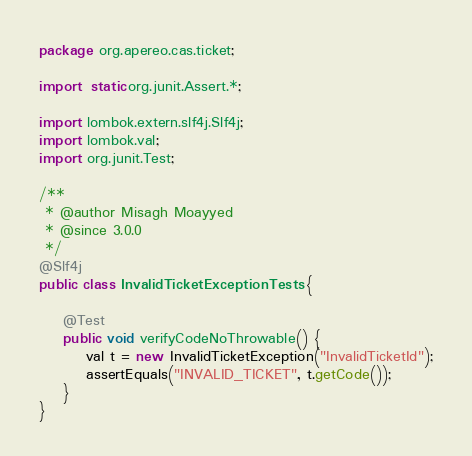Convert code to text. <code><loc_0><loc_0><loc_500><loc_500><_Java_>package org.apereo.cas.ticket;

import static org.junit.Assert.*;

import lombok.extern.slf4j.Slf4j;
import lombok.val;
import org.junit.Test;

/**
 * @author Misagh Moayyed
 * @since 3.0.0
 */
@Slf4j
public class InvalidTicketExceptionTests {

    @Test
    public void verifyCodeNoThrowable() {
        val t = new InvalidTicketException("InvalidTicketId");
        assertEquals("INVALID_TICKET", t.getCode());
    }
}
</code> 